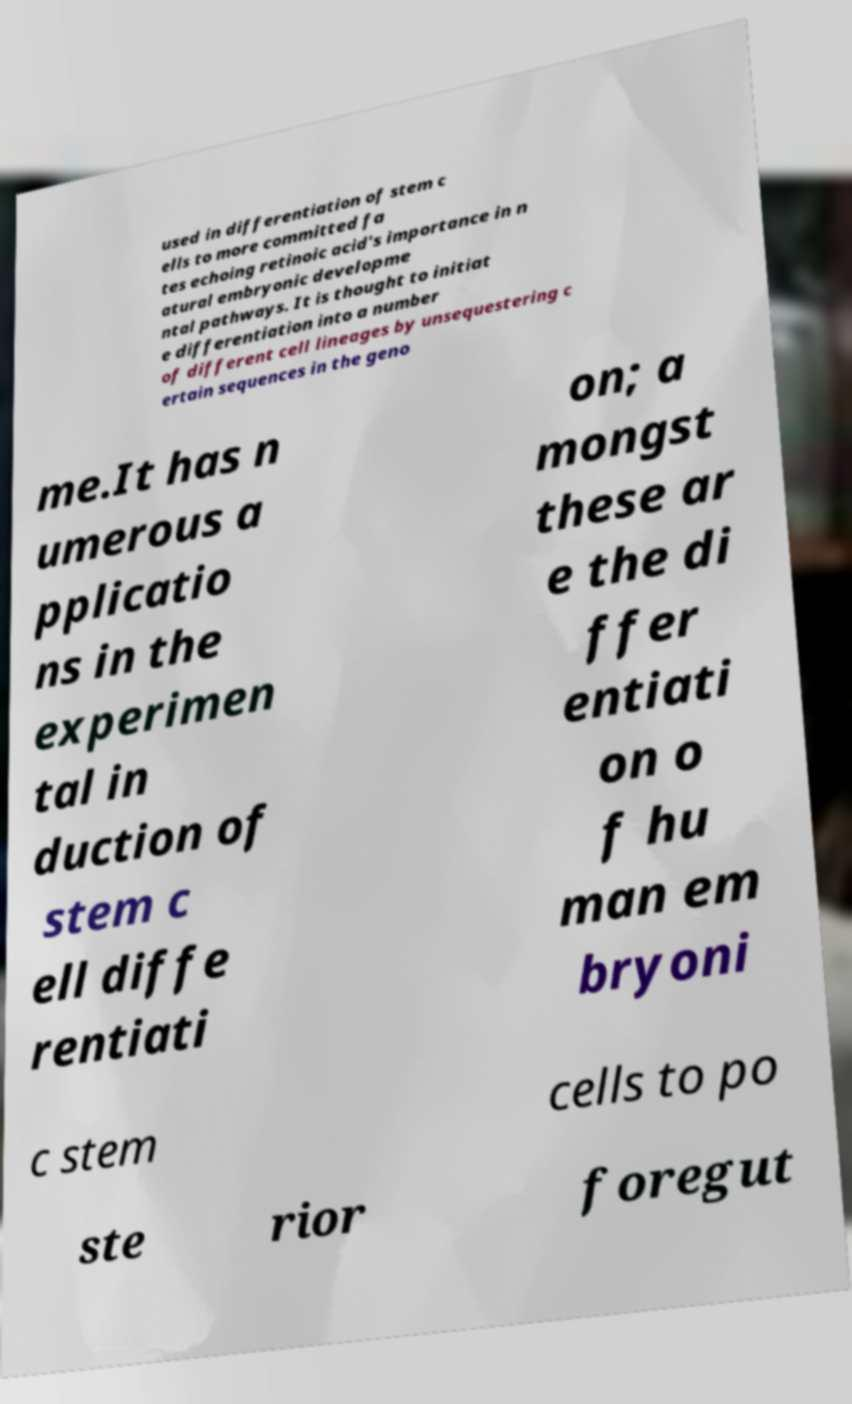What messages or text are displayed in this image? I need them in a readable, typed format. used in differentiation of stem c ells to more committed fa tes echoing retinoic acid's importance in n atural embryonic developme ntal pathways. It is thought to initiat e differentiation into a number of different cell lineages by unsequestering c ertain sequences in the geno me.It has n umerous a pplicatio ns in the experimen tal in duction of stem c ell diffe rentiati on; a mongst these ar e the di ffer entiati on o f hu man em bryoni c stem cells to po ste rior foregut 